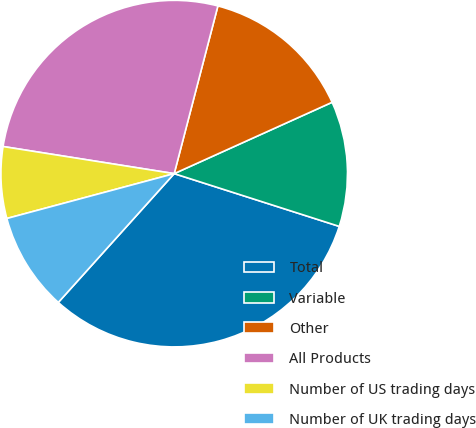<chart> <loc_0><loc_0><loc_500><loc_500><pie_chart><fcel>Total<fcel>Variable<fcel>Other<fcel>All Products<fcel>Number of US trading days<fcel>Number of UK trading days<nl><fcel>31.74%<fcel>11.68%<fcel>14.19%<fcel>26.56%<fcel>6.67%<fcel>9.17%<nl></chart> 